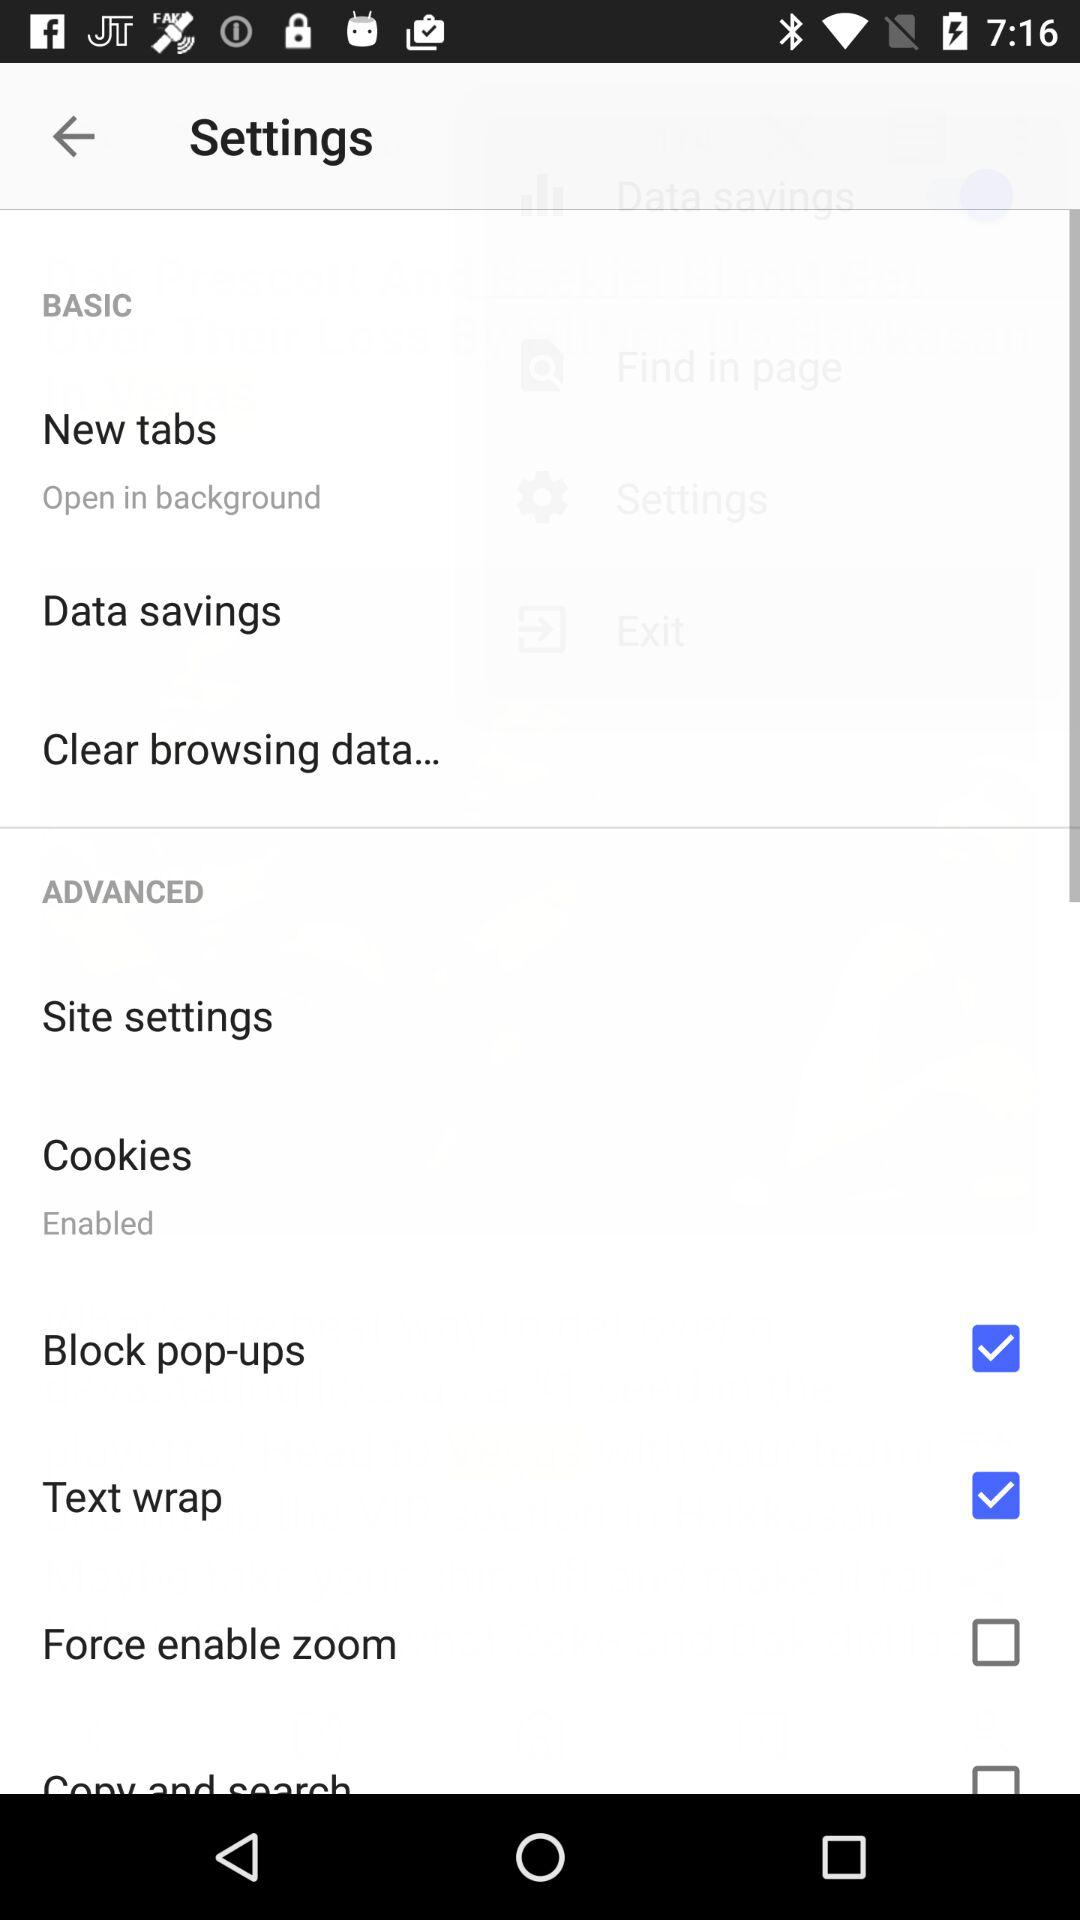What is the current status of "Text wrap"? The status of "Text wrap" is "on". 